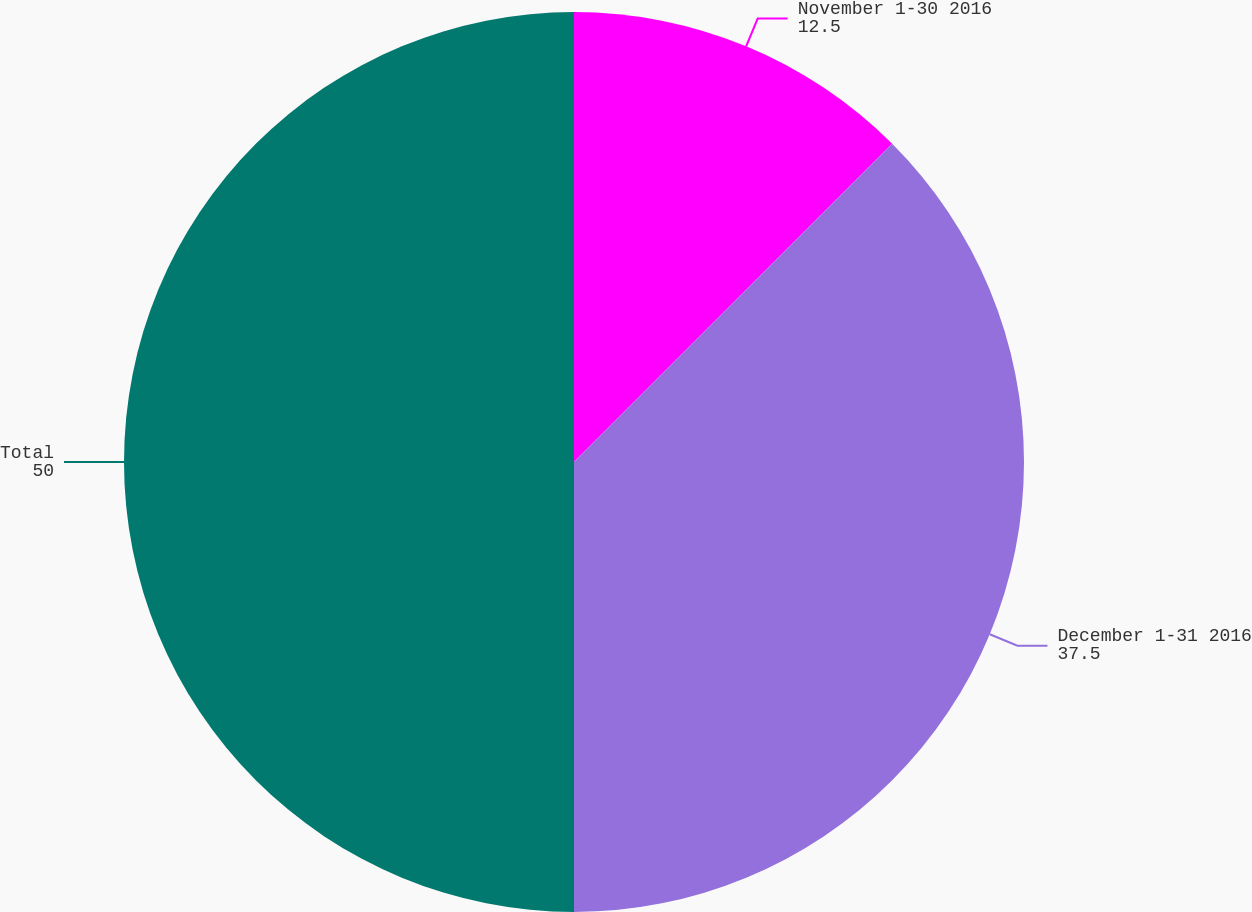Convert chart. <chart><loc_0><loc_0><loc_500><loc_500><pie_chart><fcel>November 1-30 2016<fcel>December 1-31 2016<fcel>Total<nl><fcel>12.5%<fcel>37.5%<fcel>50.0%<nl></chart> 